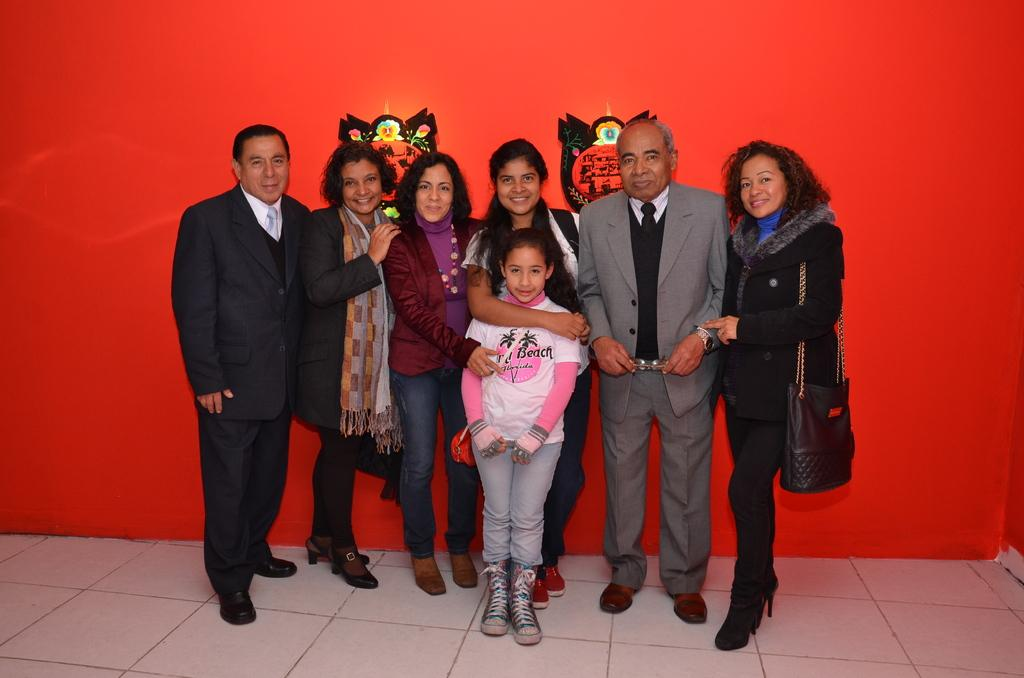How many men are in the image? There are two men in the image. How many women are in the image? There are three women in the image. Are there any children in the image? Yes, there is a girl in the image. Where are the people standing? The people are standing on the floor. What can be seen on the wall in the background? There are stickers on the wall in the background. What type of plantation is visible in the image? There is no plantation present in the image. What design elements can be seen in the scene? The provided facts do not mention any specific design elements in the image. 